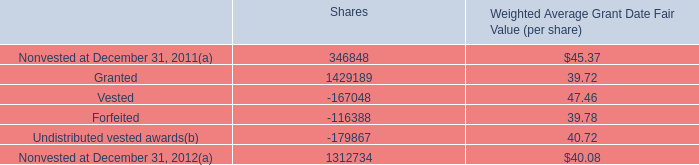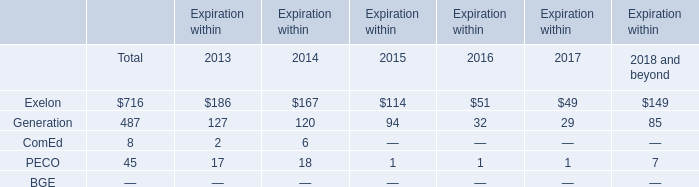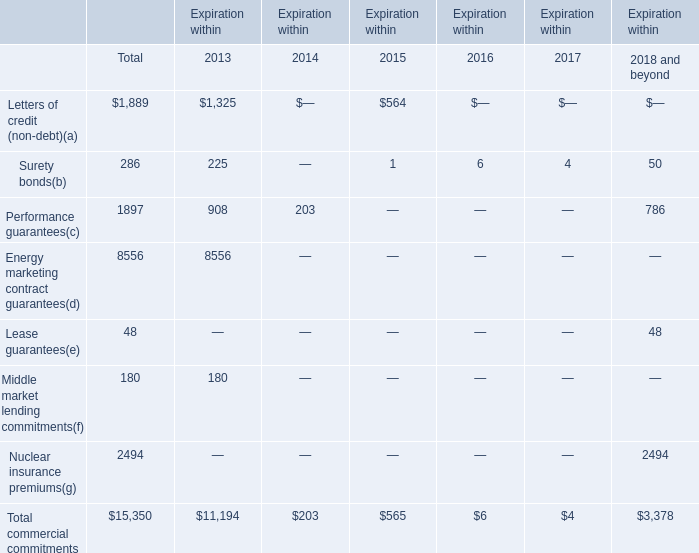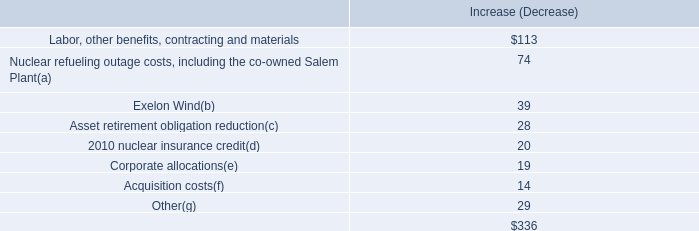In the year with the most Total commercial commitments, what is the growth rate of Performance guarantees? 
Computations: ((908 - 203) / 203)
Answer: 3.47291. 